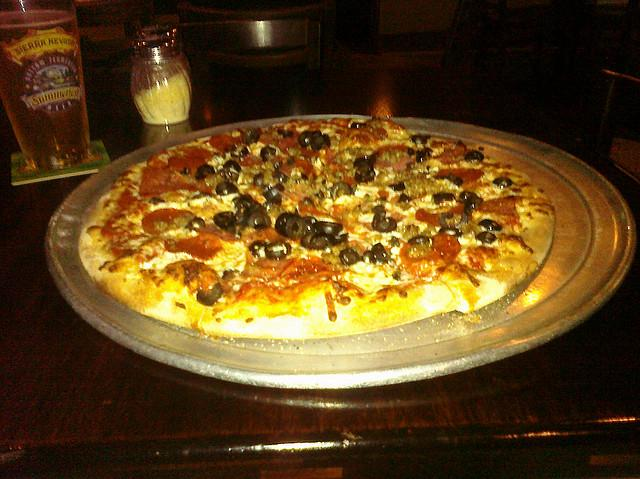What is in the shaker jar next to the beverage? Please explain your reasoning. parmesan cheese. In this scene a pizza is served. parmesan cheese is usually available to put on top of pizza at restaurants. 